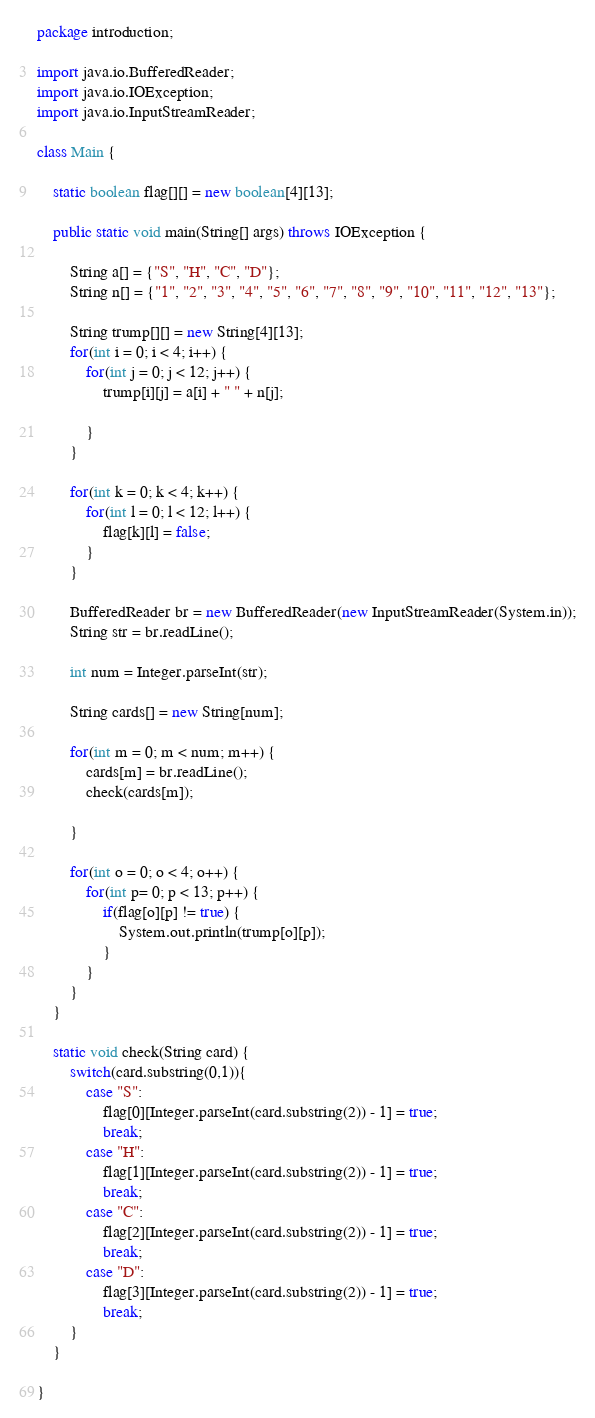<code> <loc_0><loc_0><loc_500><loc_500><_Java_>package introduction;

import java.io.BufferedReader;
import java.io.IOException;
import java.io.InputStreamReader;

class Main {
	
	static boolean flag[][] = new boolean[4][13];

	public static void main(String[] args) throws IOException {
		
		String a[] = {"S", "H", "C", "D"};
		String n[] = {"1", "2", "3", "4", "5", "6", "7", "8", "9", "10", "11", "12", "13"};
		
		String trump[][] = new String[4][13];
		for(int i = 0; i < 4; i++) {
			for(int j = 0; j < 12; j++) {
				trump[i][j] = a[i] + " " + n[j];
						
			}
		}
		
		for(int k = 0; k < 4; k++) {
			for(int l = 0; l < 12; l++) {
				flag[k][l] = false;
			}
		}
		
		BufferedReader br = new BufferedReader(new InputStreamReader(System.in));
		String str = br.readLine();
		
		int num = Integer.parseInt(str);
		
		String cards[] = new String[num];
		
		for(int m = 0; m < num; m++) {
			cards[m] = br.readLine();
			check(cards[m]);
		
		}
		
		for(int o = 0; o < 4; o++) {
			for(int p= 0; p < 13; p++) {
				if(flag[o][p] != true) {
					System.out.println(trump[o][p]);
				}
			}
		}
	}
	
	static void check(String card) {
		switch(card.substring(0,1)){
			case "S":
				flag[0][Integer.parseInt(card.substring(2)) - 1] = true;
				break;
			case "H":
				flag[1][Integer.parseInt(card.substring(2)) - 1] = true;
				break;
			case "C":
				flag[2][Integer.parseInt(card.substring(2)) - 1] = true;
				break;
			case "D":
				flag[3][Integer.parseInt(card.substring(2)) - 1] = true;
				break;
		}
	}
	
}</code> 